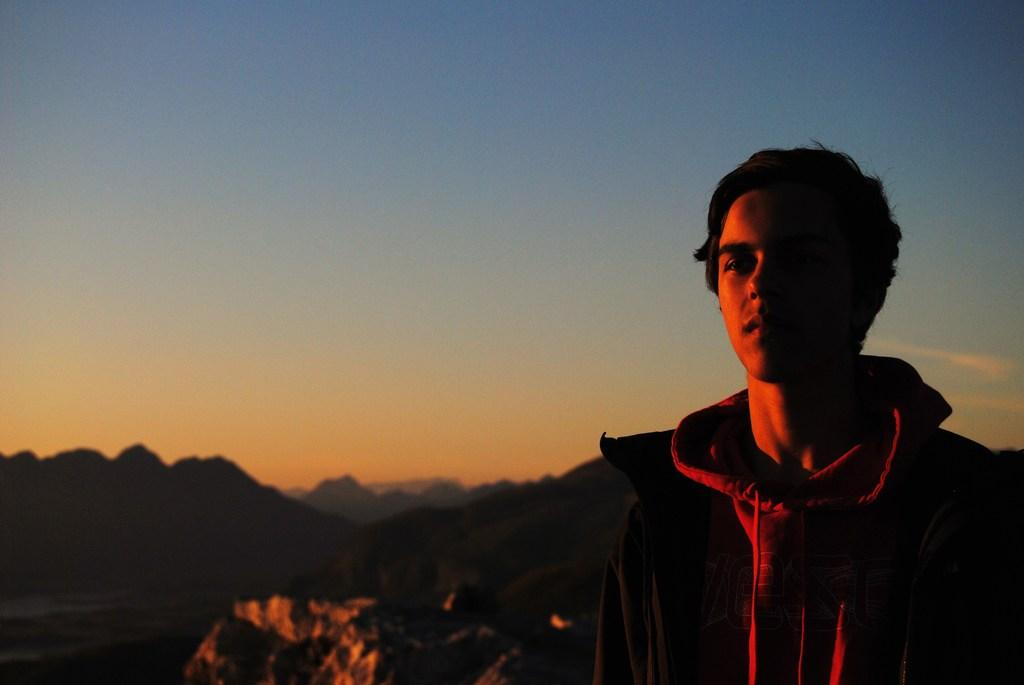Who or what is on the right side of the image? There is a person on the right side of the image. What is behind the person in the image? There are rocks behind the person. What can be seen in the distance in the image? There are mountains in the background of the image. What else is visible in the background of the image? The sky is visible in the background of the image. What is the rate of the zoo animals escaping in the image? There is no zoo or animals present in the image, so there is no rate of escape to discuss. 